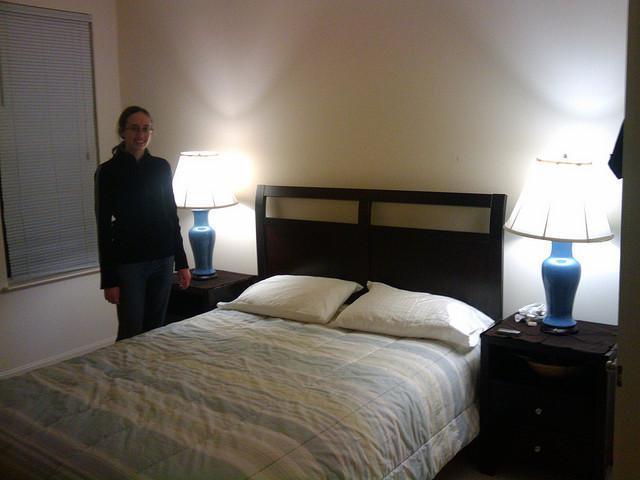How many dogs are there?
Give a very brief answer. 0. 